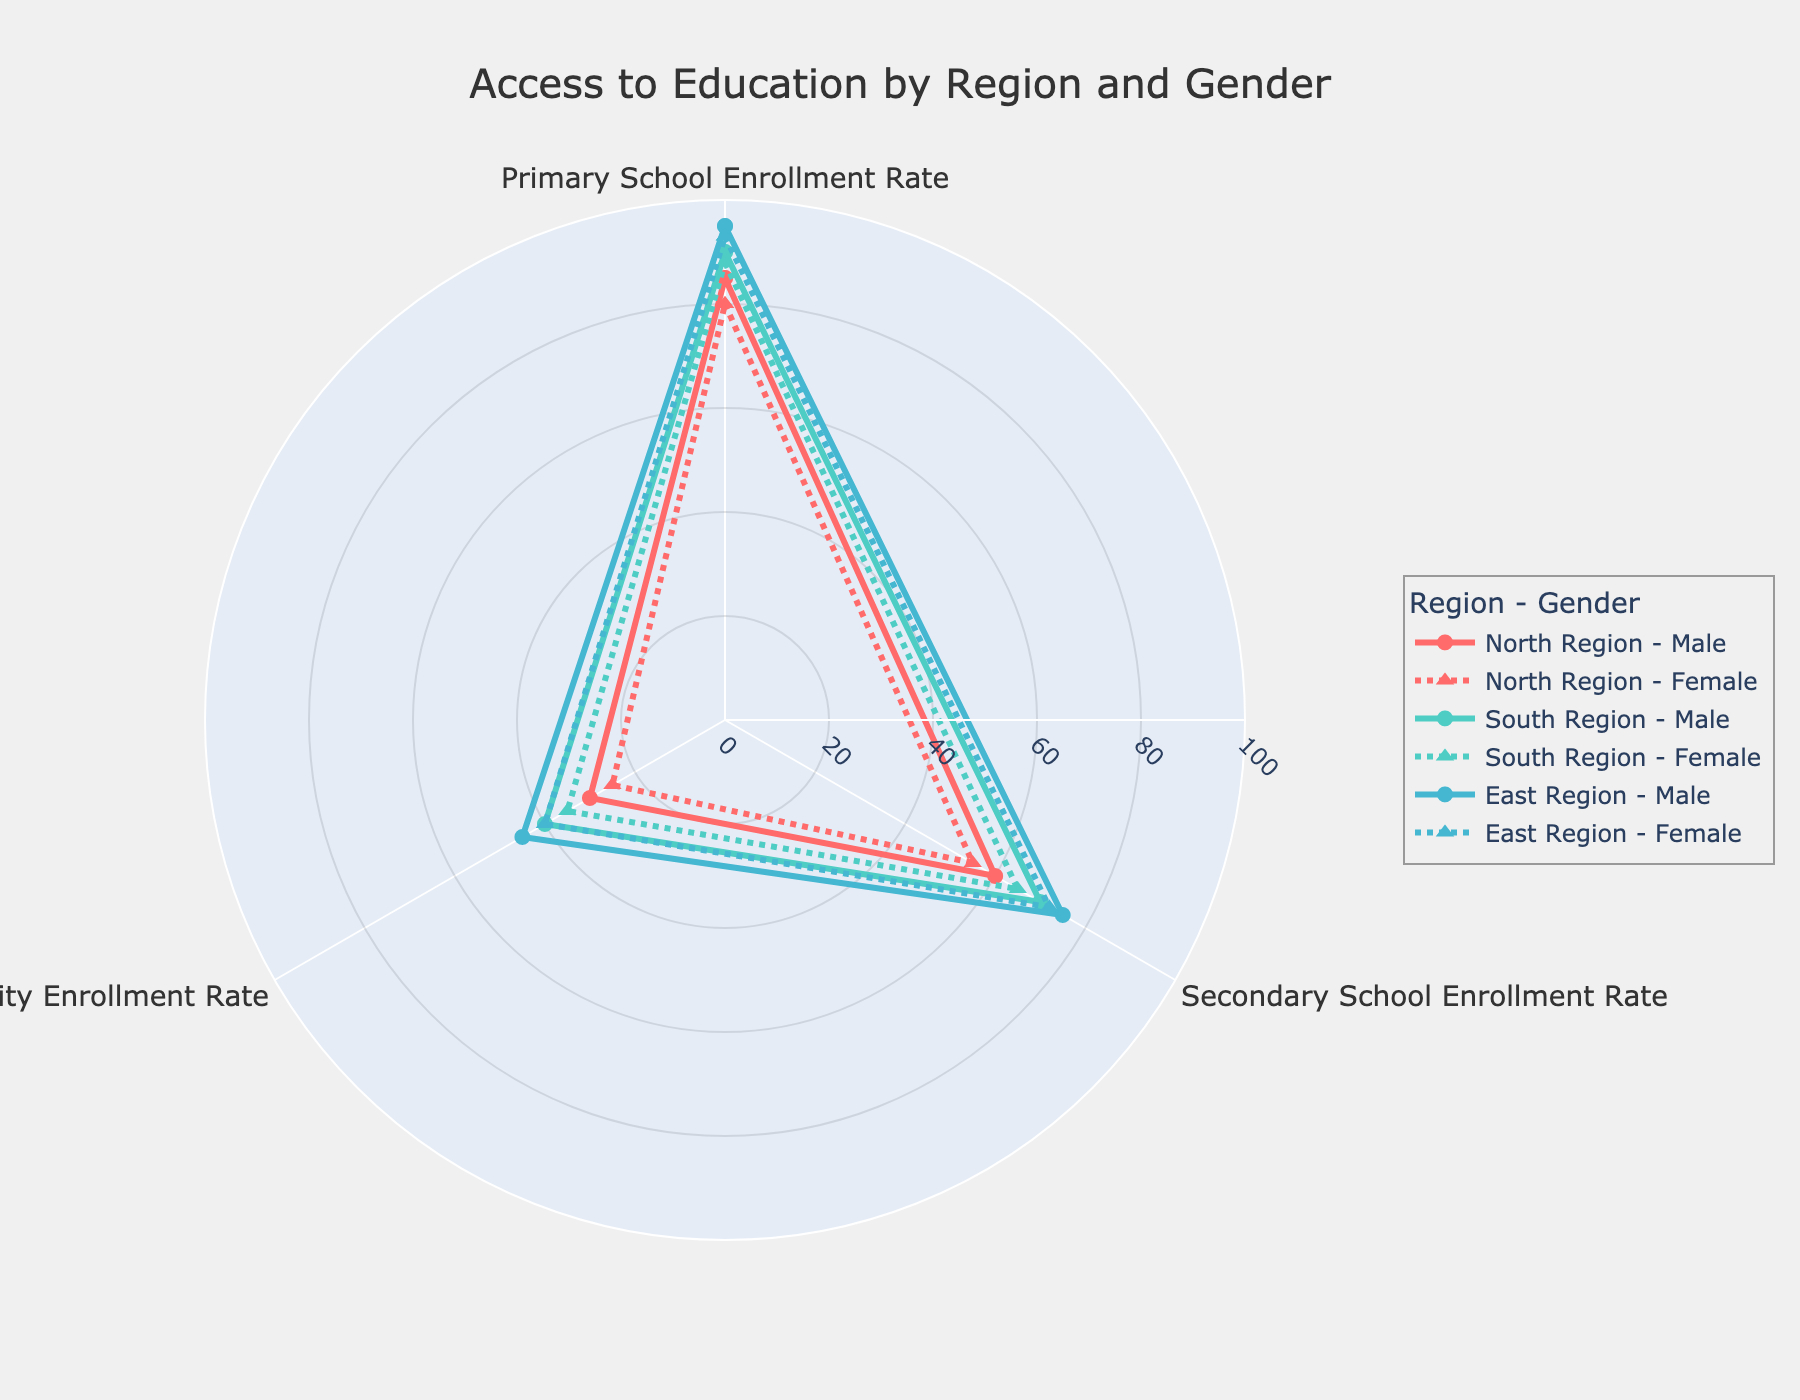What is the title of the radar chart? The title of the radar chart is located at the top of the figure. It provides a brief description of what the chart represents. In this case, the title says "Access to Education by Region and Gender".
Answer: Access to Education by Region and Gender How many regions are represented in the radar chart? By interpreting the distinct patterns and legend entries, you can see the chart represents three different regions.
Answer: Three Which region has the highest primary school enrollment rate for females? To determine this, we need to examine the female data points for primary school enrollment across all regions. The highest value is seen for the East Region.
Answer: East Region On average, which gender has a higher secondary school enrollment rate in the North Region? Calculate the average secondary school enrollment rate for males and females in the North Region. Males have a rate of 60, and females have a rate of 55. Therefore, males have a higher average rate.
Answer: Males What is the difference in university enrollment rates between males and females in the South Region? For the South Region, the male university enrollment rate is 40, and the female university enrollment rate is 35. The difference is calculated as 40 - 35.
Answer: 5 Which gender has the lowest university enrollment rate in the East Region? Looking at the university enrollment rates in the East Region, the female rate is 40, while the male rate is 45. Thus, females have the lowest rate.
Answer: Females Compare the secondary school enrollment rates of the North and South Regions for males. Which is higher? The male secondary school enrollment rate in the North Region is 60, while in the South Region it is 70. Therefore, the South Region has a higher rate.
Answer: South Region What is the total primary school enrollment rate for males across all regions? Summing the male primary school enrollment rates: North Region (85), South Region (90), East Region (95). The total is 85 + 90 + 95.
Answer: 270 Which region shows the smallest gender gap in primary school enrollment rates? By checking the male and female primary school enrollment rates for each region, we find that the North Region has an 85-80 = 5 difference, the South Region has a 2-point difference (90-88), and the East Region has a 2-point difference (95-93). The South Region and the East Region have the smallest gender gaps.
Answer: South Region, East Region In which region is the gender disparity largest in secondary school enrollment rates? Calculate the differences in secondary school enrollment rates between males and females for each region. The North Region has a 5-point difference (60-55), the South Region has a 5-point difference (70-65), and the East Region has a 3-point difference (75-72). The North and South regions have the largest disparity.
Answer: North Region, South Region 